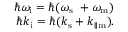<formula> <loc_0><loc_0><loc_500><loc_500>\begin{array} { r } { \hbar { \omega } _ { i } = \hbar { ( } \omega _ { s } \ + \omega _ { m } ) } \\ { \hbar { k } _ { i } = \hbar { ( } k _ { s } + k _ { \| m } ) . } \end{array}</formula> 